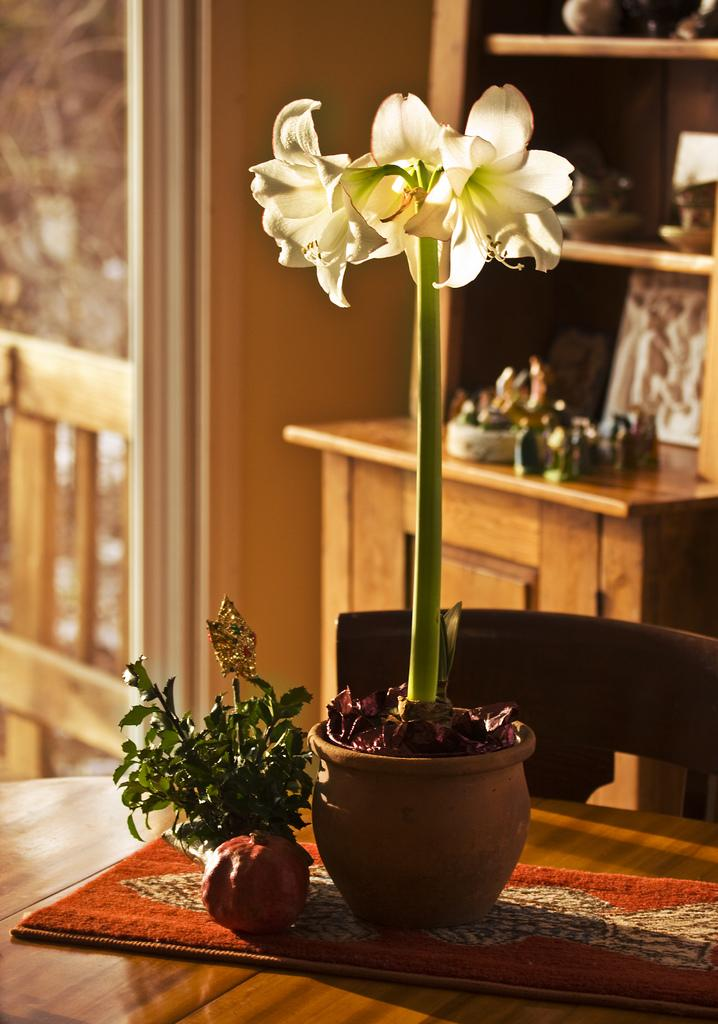What object is present in the image that contains a plant? There is a flower pot in the image that contains a flower plant. Where is the flower pot located? The flower pot is on a table. What piece of furniture is in front of the table? There is a chair in front of the table. What can be seen in the background of the image? There is a cupboard and shelves in the background of the image. What type of activity is the flower plant participating in within the image? The flower plant is not participating in any activity within the image; it is simply growing in the flower pot. 